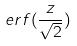<formula> <loc_0><loc_0><loc_500><loc_500>e r f ( \frac { z } { \sqrt { 2 } } )</formula> 